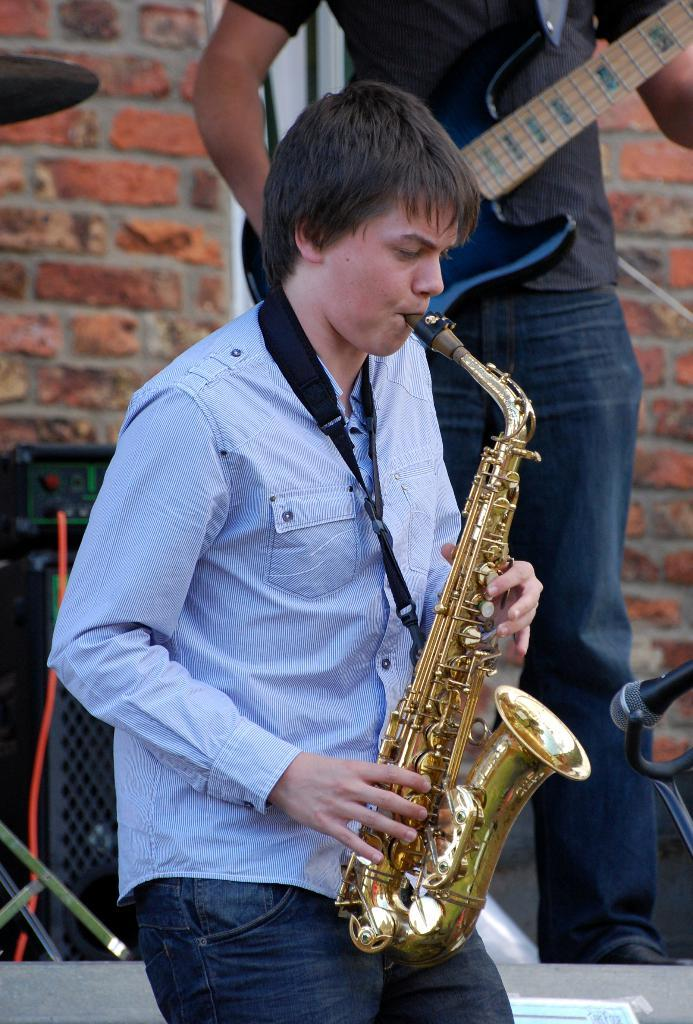What is the main subject of the image? The main subject of the image is a man. What is the man doing in the image? The man is playing a saxophone in the image. What type of jelly can be seen on the man's notebook in the image? There is no jelly or notebook present in the image; the man is playing a saxophone. 